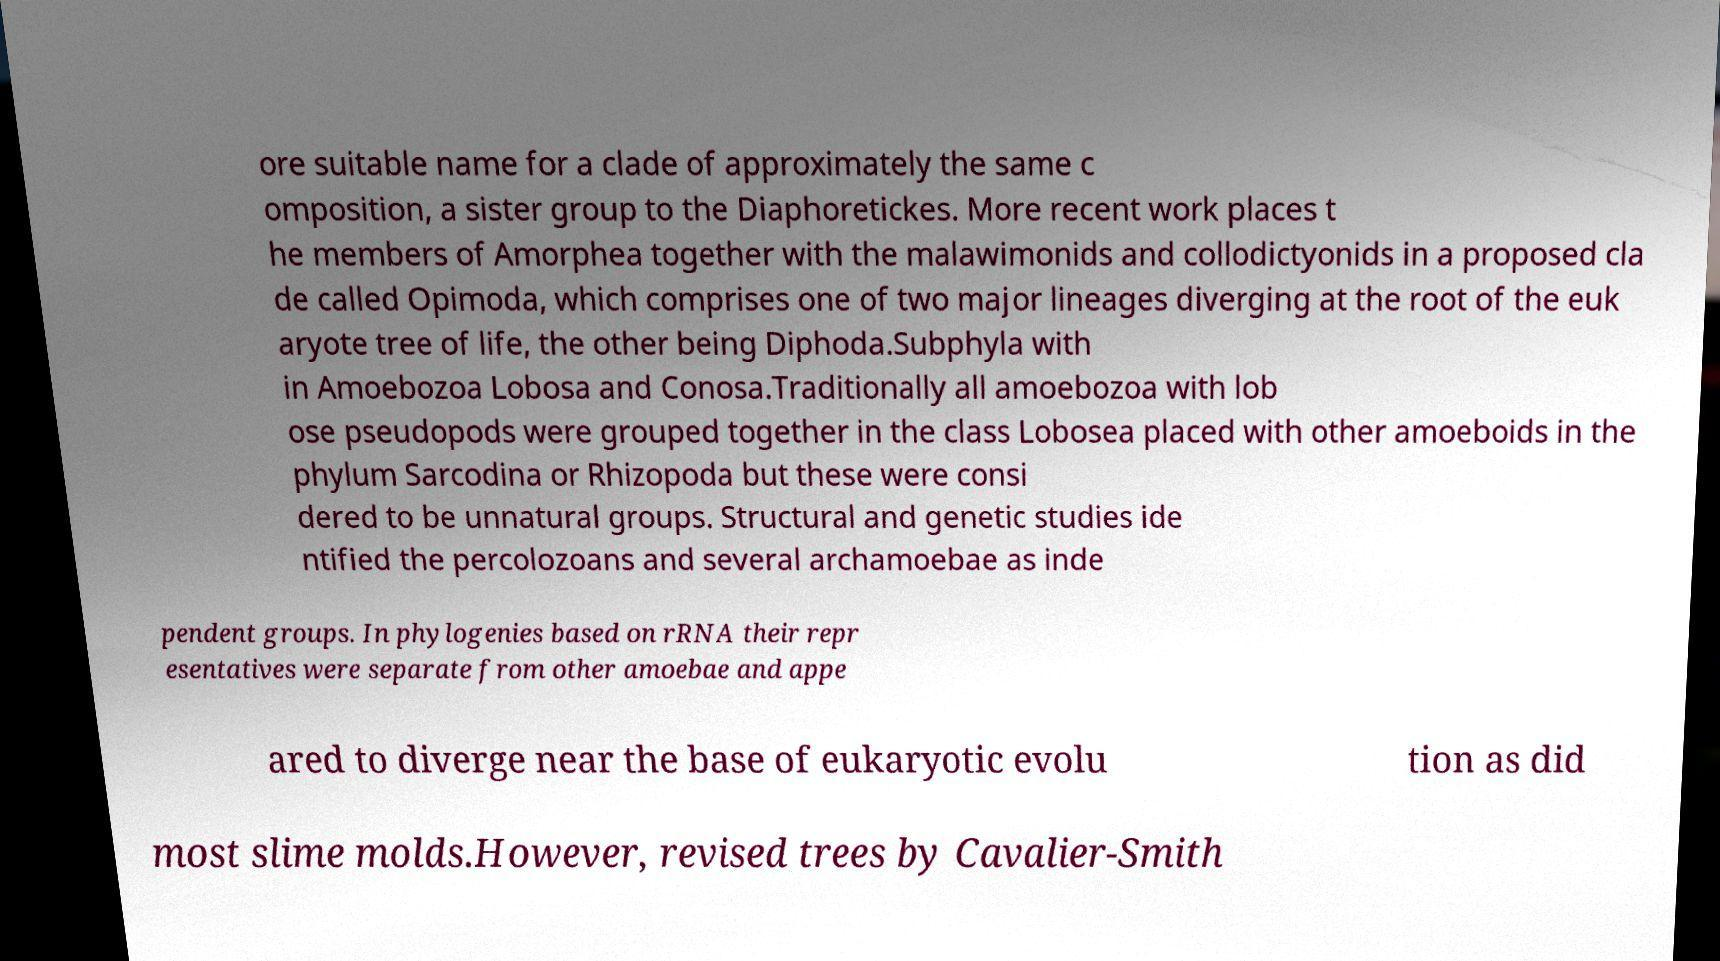What messages or text are displayed in this image? I need them in a readable, typed format. ore suitable name for a clade of approximately the same c omposition, a sister group to the Diaphoretickes. More recent work places t he members of Amorphea together with the malawimonids and collodictyonids in a proposed cla de called Opimoda, which comprises one of two major lineages diverging at the root of the euk aryote tree of life, the other being Diphoda.Subphyla with in Amoebozoa Lobosa and Conosa.Traditionally all amoebozoa with lob ose pseudopods were grouped together in the class Lobosea placed with other amoeboids in the phylum Sarcodina or Rhizopoda but these were consi dered to be unnatural groups. Structural and genetic studies ide ntified the percolozoans and several archamoebae as inde pendent groups. In phylogenies based on rRNA their repr esentatives were separate from other amoebae and appe ared to diverge near the base of eukaryotic evolu tion as did most slime molds.However, revised trees by Cavalier-Smith 